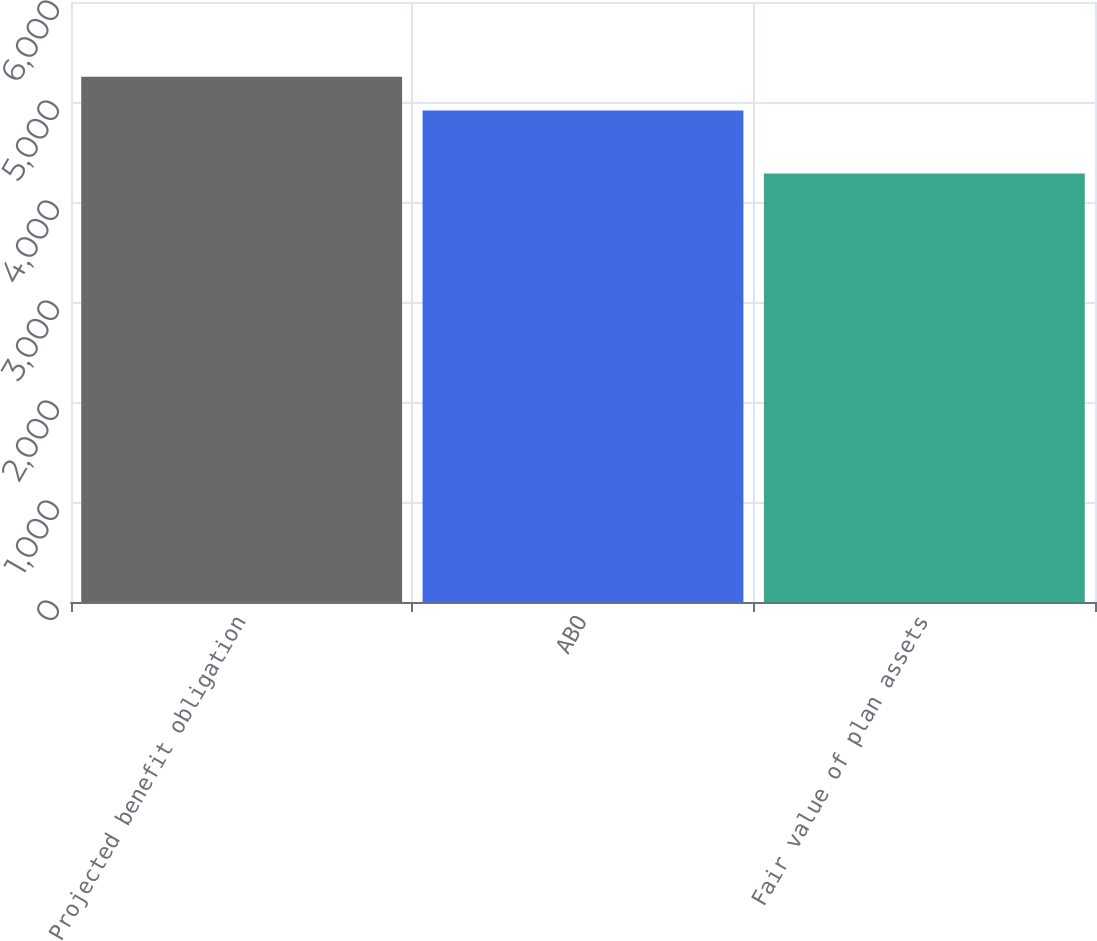<chart> <loc_0><loc_0><loc_500><loc_500><bar_chart><fcel>Projected benefit obligation<fcel>ABO<fcel>Fair value of plan assets<nl><fcel>5252.5<fcel>4914.8<fcel>4285.2<nl></chart> 